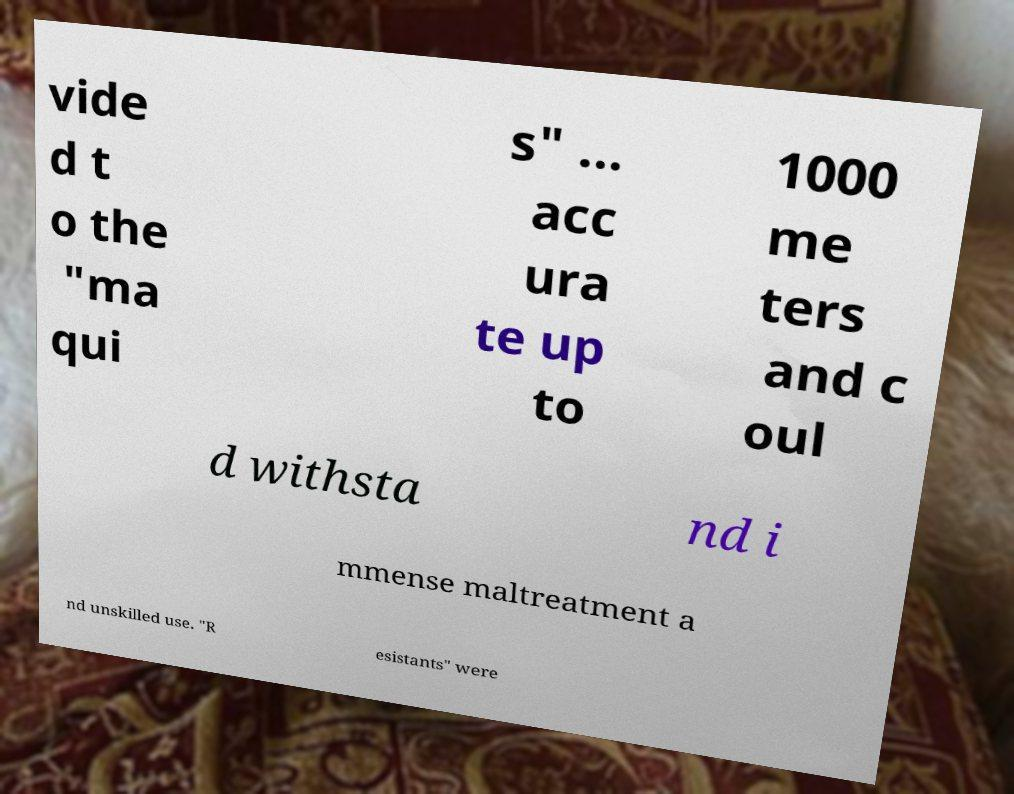Please identify and transcribe the text found in this image. vide d t o the "ma qui s" ... acc ura te up to 1000 me ters and c oul d withsta nd i mmense maltreatment a nd unskilled use. "R esistants" were 